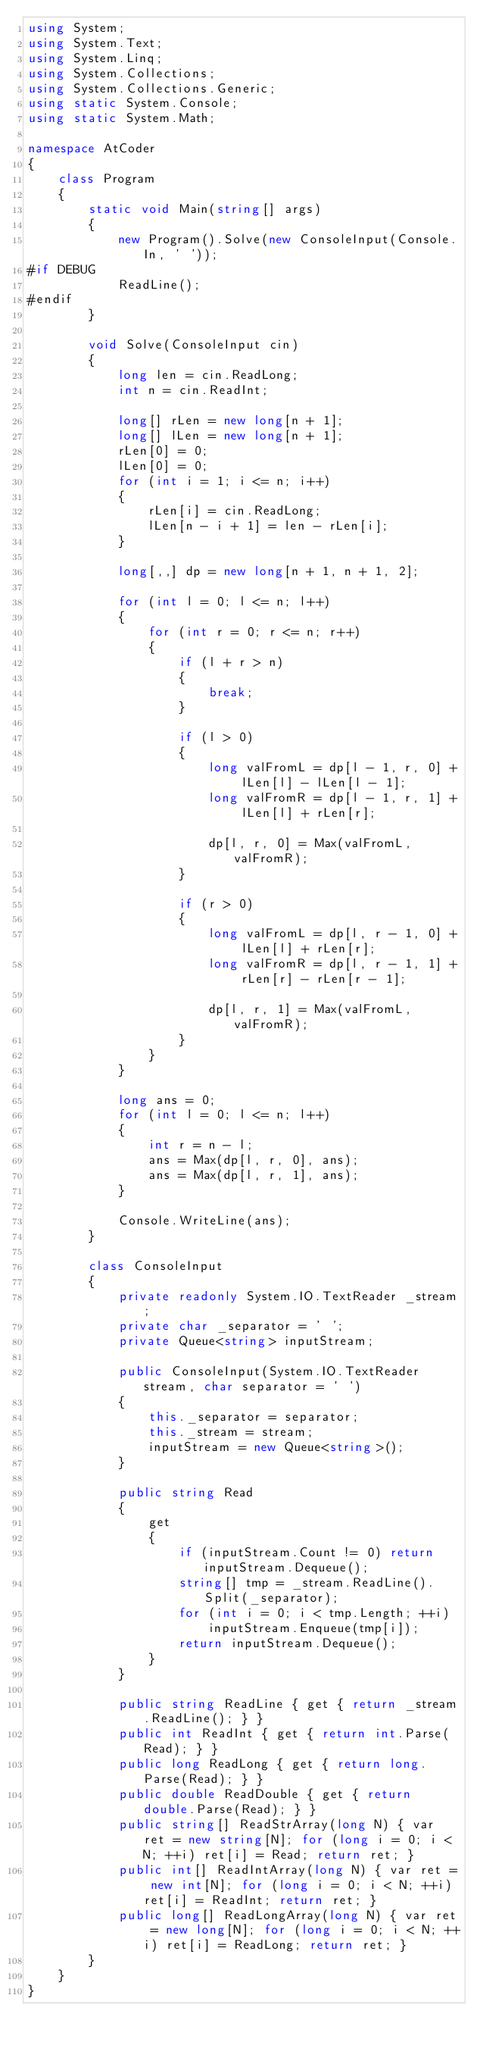Convert code to text. <code><loc_0><loc_0><loc_500><loc_500><_C#_>using System;
using System.Text;
using System.Linq;
using System.Collections;
using System.Collections.Generic;
using static System.Console;
using static System.Math;

namespace AtCoder
{
    class Program
    {
        static void Main(string[] args)
        {
            new Program().Solve(new ConsoleInput(Console.In, ' '));
#if DEBUG
            ReadLine();
#endif
        }

        void Solve(ConsoleInput cin)
        {
            long len = cin.ReadLong;
            int n = cin.ReadInt;

            long[] rLen = new long[n + 1];
            long[] lLen = new long[n + 1];
            rLen[0] = 0;
            lLen[0] = 0;
            for (int i = 1; i <= n; i++)
            {
                rLen[i] = cin.ReadLong;
                lLen[n - i + 1] = len - rLen[i];
            }

            long[,,] dp = new long[n + 1, n + 1, 2];

            for (int l = 0; l <= n; l++)
            {
                for (int r = 0; r <= n; r++)
                {
                    if (l + r > n)
                    {
                        break;
                    }

                    if (l > 0)
                    {
                        long valFromL = dp[l - 1, r, 0] + lLen[l] - lLen[l - 1];
                        long valFromR = dp[l - 1, r, 1] + lLen[l] + rLen[r];

                        dp[l, r, 0] = Max(valFromL, valFromR);
                    }

                    if (r > 0)
                    {
                        long valFromL = dp[l, r - 1, 0] + lLen[l] + rLen[r];
                        long valFromR = dp[l, r - 1, 1] + rLen[r] - rLen[r - 1];

                        dp[l, r, 1] = Max(valFromL, valFromR);
                    }
                }
            }

            long ans = 0;
            for (int l = 0; l <= n; l++)
            {
                int r = n - l;
                ans = Max(dp[l, r, 0], ans);
                ans = Max(dp[l, r, 1], ans);
            }

            Console.WriteLine(ans);
        }

        class ConsoleInput
        {
            private readonly System.IO.TextReader _stream;
            private char _separator = ' ';
            private Queue<string> inputStream;

            public ConsoleInput(System.IO.TextReader stream, char separator = ' ')
            {
                this._separator = separator;
                this._stream = stream;
                inputStream = new Queue<string>();
            }

            public string Read
            {
                get
                {
                    if (inputStream.Count != 0) return inputStream.Dequeue();
                    string[] tmp = _stream.ReadLine().Split(_separator);
                    for (int i = 0; i < tmp.Length; ++i)
                        inputStream.Enqueue(tmp[i]);
                    return inputStream.Dequeue();
                }
            }

            public string ReadLine { get { return _stream.ReadLine(); } }
            public int ReadInt { get { return int.Parse(Read); } }
            public long ReadLong { get { return long.Parse(Read); } }
            public double ReadDouble { get { return double.Parse(Read); } }
            public string[] ReadStrArray(long N) { var ret = new string[N]; for (long i = 0; i < N; ++i) ret[i] = Read; return ret; }
            public int[] ReadIntArray(long N) { var ret = new int[N]; for (long i = 0; i < N; ++i) ret[i] = ReadInt; return ret; }
            public long[] ReadLongArray(long N) { var ret = new long[N]; for (long i = 0; i < N; ++i) ret[i] = ReadLong; return ret; }
        }
    }
}</code> 